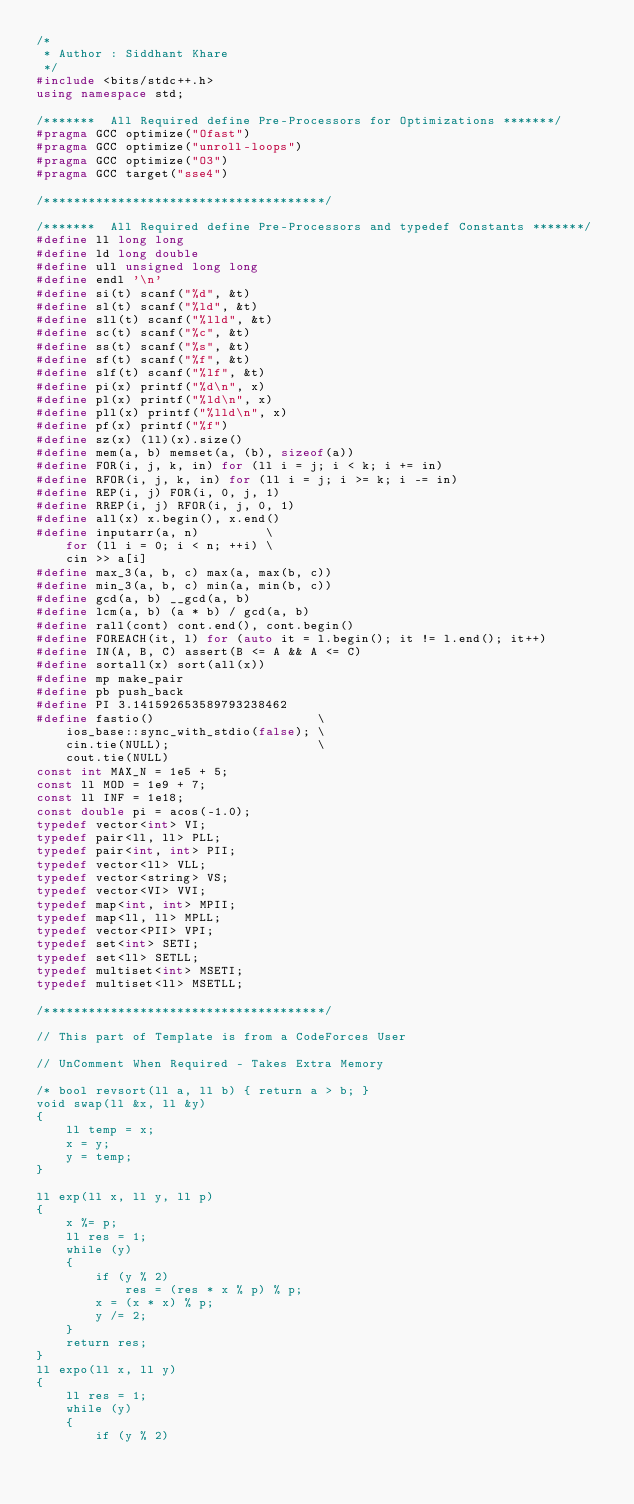<code> <loc_0><loc_0><loc_500><loc_500><_C++_>/*
 * Author : Siddhant Khare
 */
#include <bits/stdc++.h>
using namespace std;

/*******  All Required define Pre-Processors for Optimizations *******/
#pragma GCC optimize("Ofast")
#pragma GCC optimize("unroll-loops")
#pragma GCC optimize("O3")
#pragma GCC target("sse4")

/**************************************/

/*******  All Required define Pre-Processors and typedef Constants *******/
#define ll long long
#define ld long double
#define ull unsigned long long
#define endl '\n'
#define si(t) scanf("%d", &t)
#define sl(t) scanf("%ld", &t)
#define sll(t) scanf("%lld", &t)
#define sc(t) scanf("%c", &t)
#define ss(t) scanf("%s", &t)
#define sf(t) scanf("%f", &t)
#define slf(t) scanf("%lf", &t)
#define pi(x) printf("%d\n", x)
#define pl(x) printf("%ld\n", x)
#define pll(x) printf("%lld\n", x)
#define pf(x) printf("%f")
#define sz(x) (ll)(x).size()
#define mem(a, b) memset(a, (b), sizeof(a))
#define FOR(i, j, k, in) for (ll i = j; i < k; i += in)
#define RFOR(i, j, k, in) for (ll i = j; i >= k; i -= in)
#define REP(i, j) FOR(i, 0, j, 1)
#define RREP(i, j) RFOR(i, j, 0, 1)
#define all(x) x.begin(), x.end()
#define inputarr(a, n)         \
    for (ll i = 0; i < n; ++i) \
    cin >> a[i]
#define max_3(a, b, c) max(a, max(b, c))
#define min_3(a, b, c) min(a, min(b, c))
#define gcd(a, b) __gcd(a, b)
#define lcm(a, b) (a * b) / gcd(a, b)
#define rall(cont) cont.end(), cont.begin()
#define FOREACH(it, l) for (auto it = l.begin(); it != l.end(); it++)
#define IN(A, B, C) assert(B <= A && A <= C)
#define sortall(x) sort(all(x))
#define mp make_pair
#define pb push_back
#define PI 3.141592653589793238462
#define fastio()                      \
    ios_base::sync_with_stdio(false); \
    cin.tie(NULL);                    \
    cout.tie(NULL)
const int MAX_N = 1e5 + 5;
const ll MOD = 1e9 + 7;
const ll INF = 1e18;
const double pi = acos(-1.0);
typedef vector<int> VI;
typedef pair<ll, ll> PLL;
typedef pair<int, int> PII;
typedef vector<ll> VLL;
typedef vector<string> VS;
typedef vector<VI> VVI;
typedef map<int, int> MPII;
typedef map<ll, ll> MPLL;
typedef vector<PII> VPI;
typedef set<int> SETI;
typedef set<ll> SETLL;
typedef multiset<int> MSETI;
typedef multiset<ll> MSETLL;

/**************************************/

// This part of Template is from a CodeForces User

// UnComment When Required - Takes Extra Memory

/* bool revsort(ll a, ll b) { return a > b; }
void swap(ll &x, ll &y)
{
    ll temp = x;
    x = y;
    y = temp;
}

ll exp(ll x, ll y, ll p)
{
    x %= p;
    ll res = 1;
    while (y)
    {
        if (y % 2)
            res = (res * x % p) % p;
        x = (x * x) % p;
        y /= 2;
    }
    return res;
}
ll expo(ll x, ll y)
{
    ll res = 1;
    while (y)
    {
        if (y % 2)</code> 